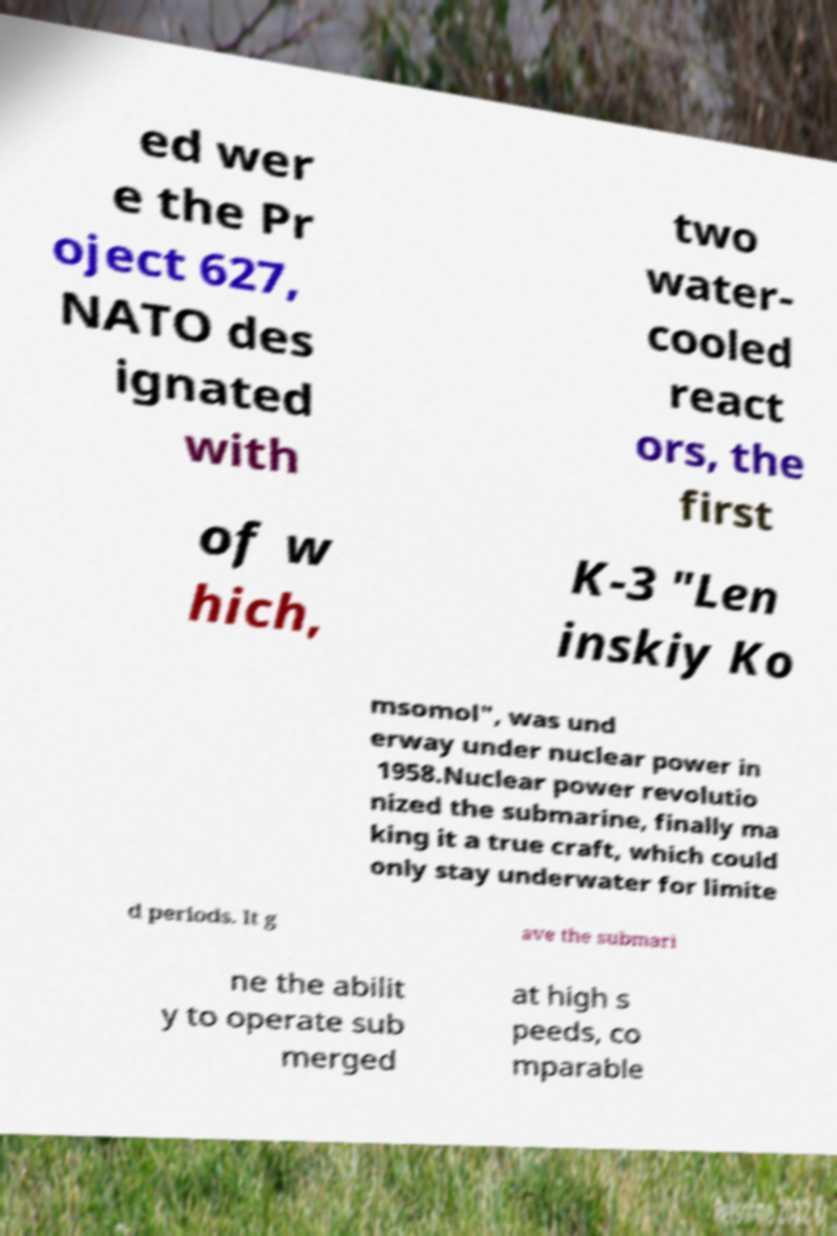Please identify and transcribe the text found in this image. ed wer e the Pr oject 627, NATO des ignated with two water- cooled react ors, the first of w hich, K-3 "Len inskiy Ko msomol", was und erway under nuclear power in 1958.Nuclear power revolutio nized the submarine, finally ma king it a true craft, which could only stay underwater for limite d periods. It g ave the submari ne the abilit y to operate sub merged at high s peeds, co mparable 